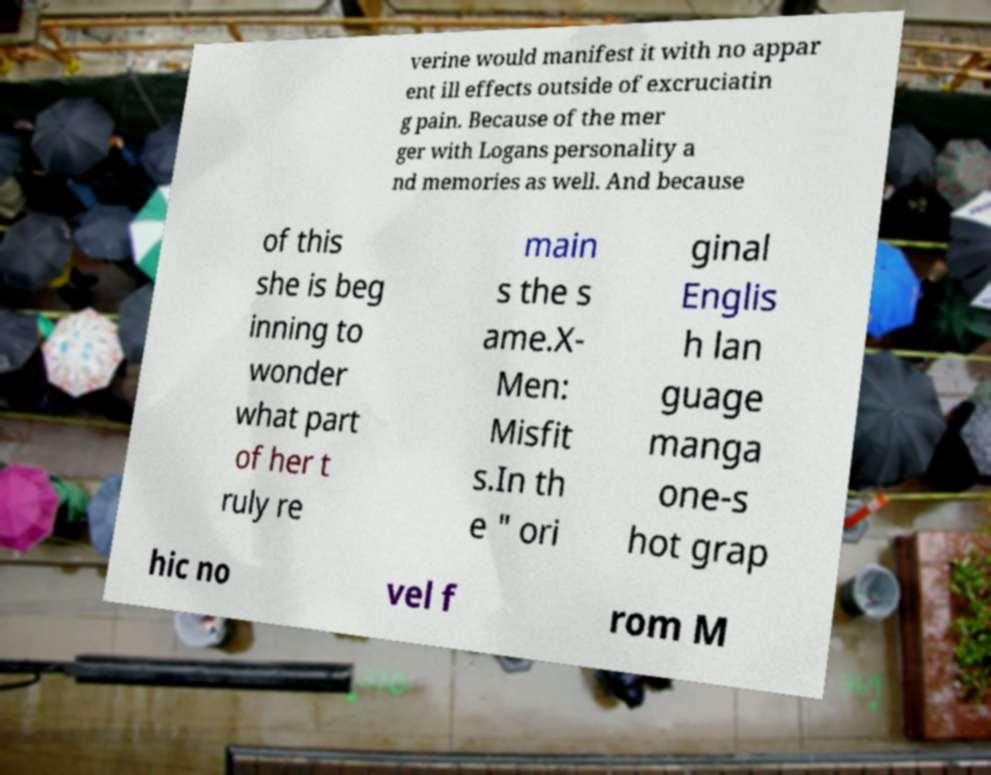What messages or text are displayed in this image? I need them in a readable, typed format. verine would manifest it with no appar ent ill effects outside of excruciatin g pain. Because of the mer ger with Logans personality a nd memories as well. And because of this she is beg inning to wonder what part of her t ruly re main s the s ame.X- Men: Misfit s.In th e " ori ginal Englis h lan guage manga one-s hot grap hic no vel f rom M 